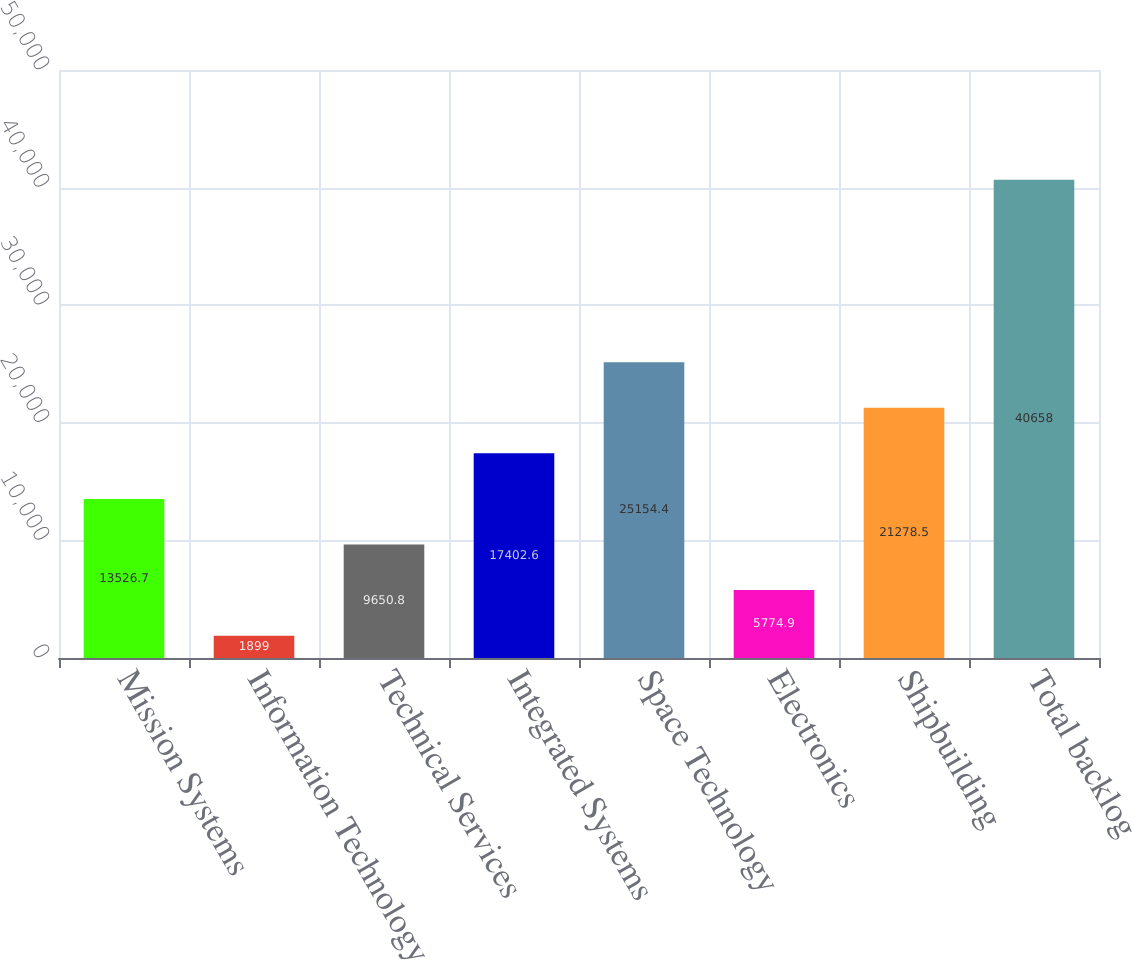Convert chart. <chart><loc_0><loc_0><loc_500><loc_500><bar_chart><fcel>Mission Systems<fcel>Information Technology<fcel>Technical Services<fcel>Integrated Systems<fcel>Space Technology<fcel>Electronics<fcel>Shipbuilding<fcel>Total backlog<nl><fcel>13526.7<fcel>1899<fcel>9650.8<fcel>17402.6<fcel>25154.4<fcel>5774.9<fcel>21278.5<fcel>40658<nl></chart> 